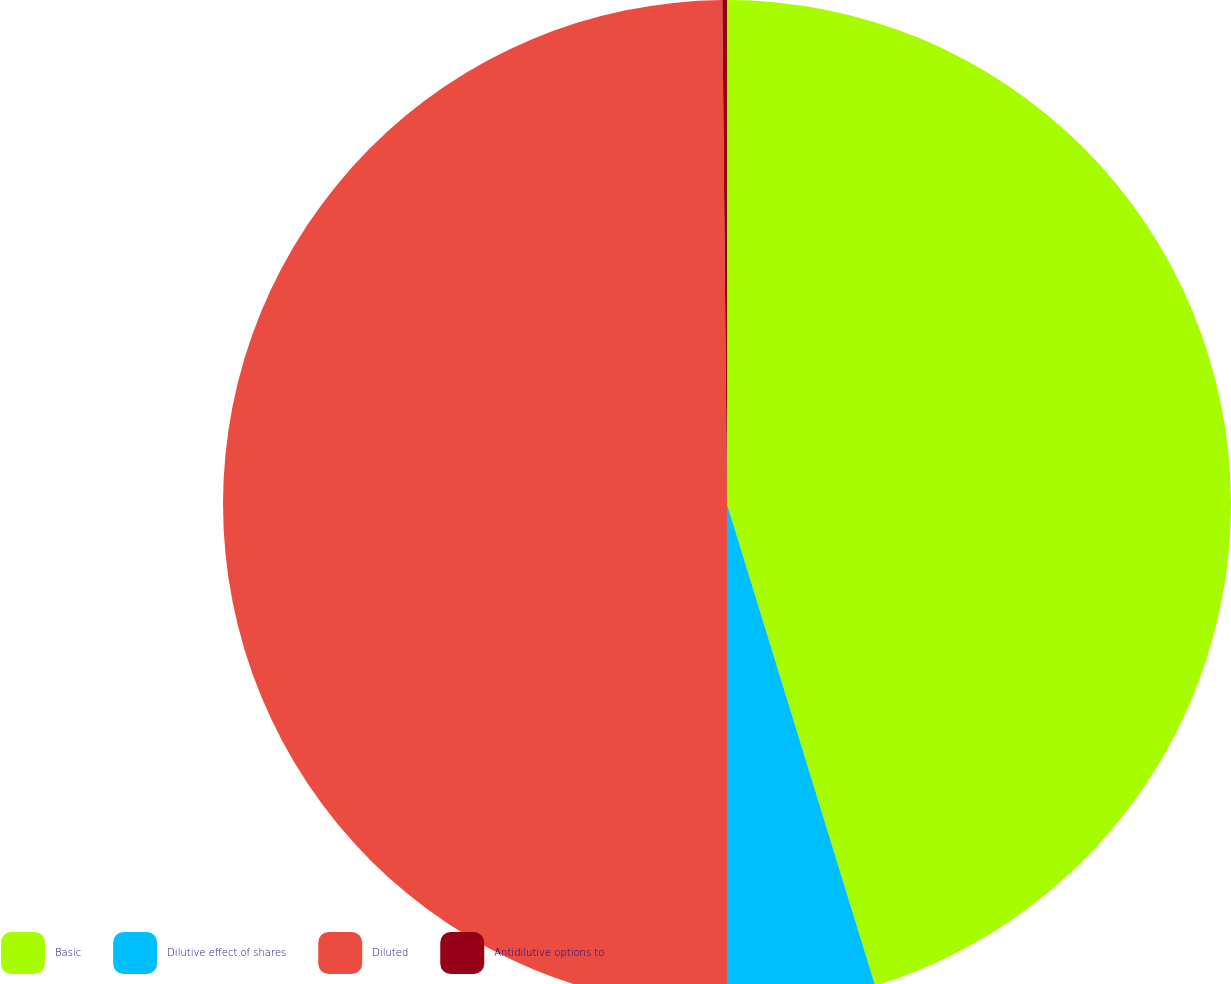Convert chart to OTSL. <chart><loc_0><loc_0><loc_500><loc_500><pie_chart><fcel>Basic<fcel>Dilutive effect of shares<fcel>Diluted<fcel>Antidilutive options to<nl><fcel>45.25%<fcel>4.75%<fcel>49.85%<fcel>0.15%<nl></chart> 